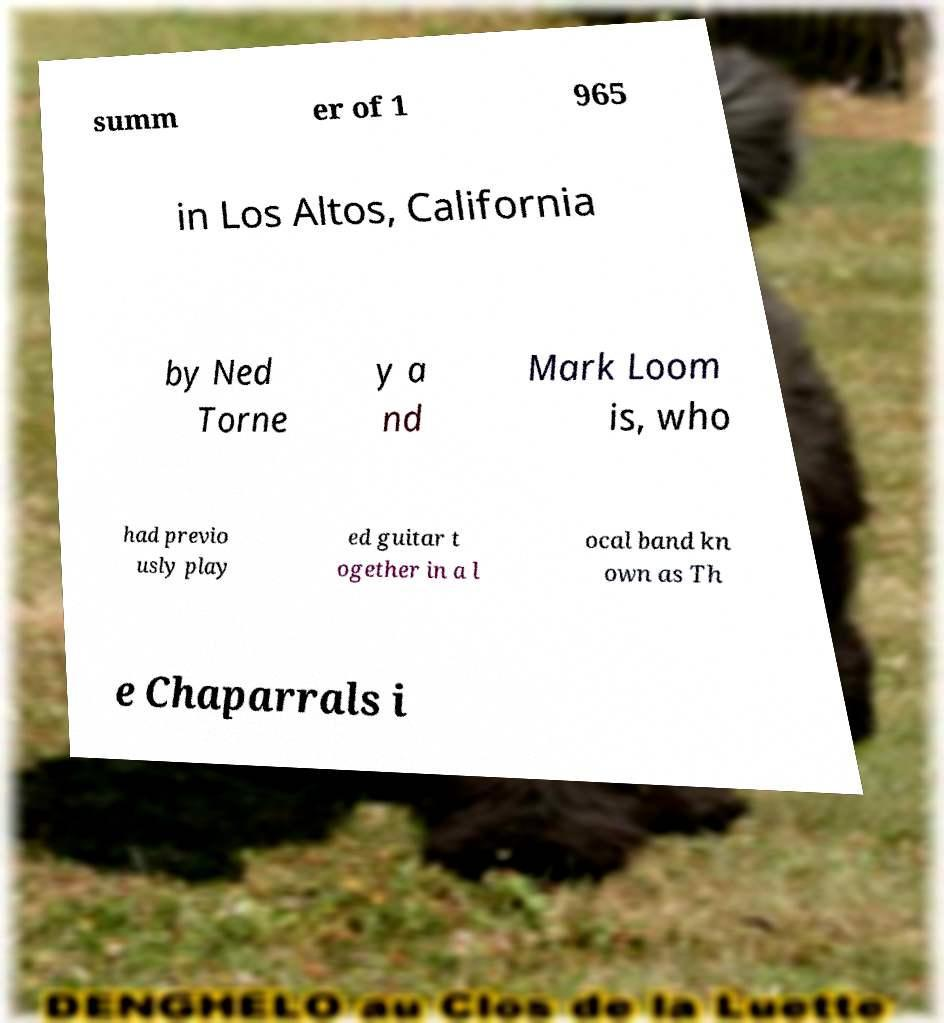I need the written content from this picture converted into text. Can you do that? summ er of 1 965 in Los Altos, California by Ned Torne y a nd Mark Loom is, who had previo usly play ed guitar t ogether in a l ocal band kn own as Th e Chaparrals i 